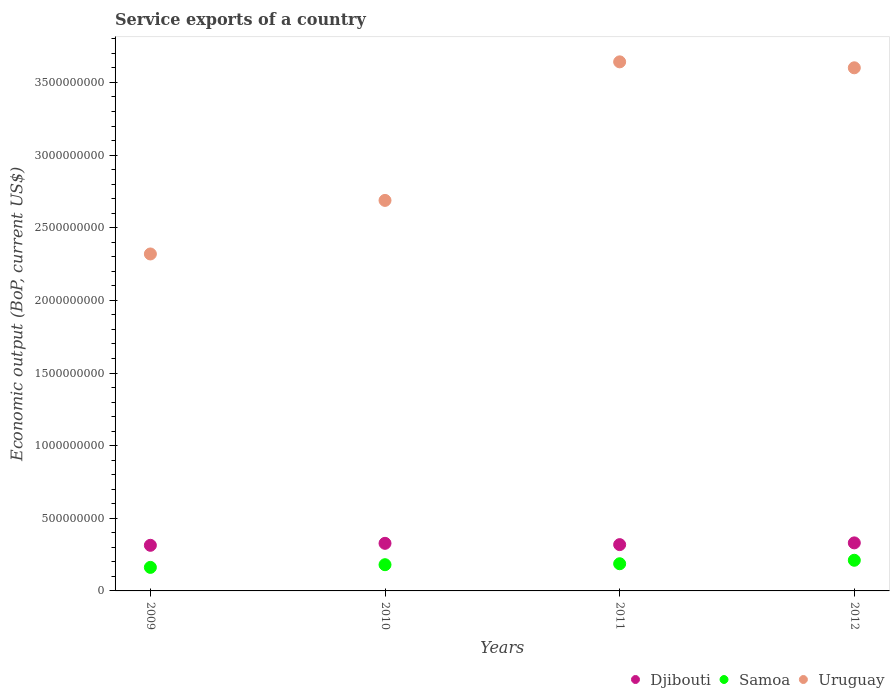How many different coloured dotlines are there?
Provide a succinct answer. 3. Is the number of dotlines equal to the number of legend labels?
Keep it short and to the point. Yes. What is the service exports in Djibouti in 2012?
Provide a short and direct response. 3.31e+08. Across all years, what is the maximum service exports in Uruguay?
Your response must be concise. 3.64e+09. Across all years, what is the minimum service exports in Samoa?
Give a very brief answer. 1.62e+08. In which year was the service exports in Samoa maximum?
Offer a very short reply. 2012. What is the total service exports in Samoa in the graph?
Your response must be concise. 7.41e+08. What is the difference between the service exports in Uruguay in 2009 and that in 2012?
Make the answer very short. -1.28e+09. What is the difference between the service exports in Uruguay in 2009 and the service exports in Djibouti in 2010?
Your answer should be very brief. 1.99e+09. What is the average service exports in Uruguay per year?
Your response must be concise. 3.06e+09. In the year 2009, what is the difference between the service exports in Samoa and service exports in Uruguay?
Give a very brief answer. -2.16e+09. What is the ratio of the service exports in Samoa in 2009 to that in 2011?
Offer a terse response. 0.87. What is the difference between the highest and the second highest service exports in Djibouti?
Provide a succinct answer. 3.07e+06. What is the difference between the highest and the lowest service exports in Djibouti?
Ensure brevity in your answer.  1.67e+07. Is the sum of the service exports in Djibouti in 2011 and 2012 greater than the maximum service exports in Samoa across all years?
Offer a very short reply. Yes. Is it the case that in every year, the sum of the service exports in Djibouti and service exports in Samoa  is greater than the service exports in Uruguay?
Make the answer very short. No. Is the service exports in Uruguay strictly less than the service exports in Samoa over the years?
Offer a very short reply. No. How many years are there in the graph?
Make the answer very short. 4. Are the values on the major ticks of Y-axis written in scientific E-notation?
Your response must be concise. No. Does the graph contain grids?
Provide a short and direct response. No. What is the title of the graph?
Offer a very short reply. Service exports of a country. What is the label or title of the X-axis?
Ensure brevity in your answer.  Years. What is the label or title of the Y-axis?
Ensure brevity in your answer.  Economic output (BoP, current US$). What is the Economic output (BoP, current US$) of Djibouti in 2009?
Keep it short and to the point. 3.14e+08. What is the Economic output (BoP, current US$) of Samoa in 2009?
Make the answer very short. 1.62e+08. What is the Economic output (BoP, current US$) of Uruguay in 2009?
Give a very brief answer. 2.32e+09. What is the Economic output (BoP, current US$) in Djibouti in 2010?
Your response must be concise. 3.28e+08. What is the Economic output (BoP, current US$) in Samoa in 2010?
Your answer should be very brief. 1.80e+08. What is the Economic output (BoP, current US$) in Uruguay in 2010?
Your response must be concise. 2.69e+09. What is the Economic output (BoP, current US$) in Djibouti in 2011?
Your response must be concise. 3.19e+08. What is the Economic output (BoP, current US$) in Samoa in 2011?
Give a very brief answer. 1.87e+08. What is the Economic output (BoP, current US$) in Uruguay in 2011?
Make the answer very short. 3.64e+09. What is the Economic output (BoP, current US$) of Djibouti in 2012?
Your response must be concise. 3.31e+08. What is the Economic output (BoP, current US$) in Samoa in 2012?
Your response must be concise. 2.11e+08. What is the Economic output (BoP, current US$) of Uruguay in 2012?
Your answer should be very brief. 3.60e+09. Across all years, what is the maximum Economic output (BoP, current US$) of Djibouti?
Provide a succinct answer. 3.31e+08. Across all years, what is the maximum Economic output (BoP, current US$) in Samoa?
Your answer should be compact. 2.11e+08. Across all years, what is the maximum Economic output (BoP, current US$) of Uruguay?
Offer a very short reply. 3.64e+09. Across all years, what is the minimum Economic output (BoP, current US$) of Djibouti?
Your answer should be compact. 3.14e+08. Across all years, what is the minimum Economic output (BoP, current US$) in Samoa?
Offer a terse response. 1.62e+08. Across all years, what is the minimum Economic output (BoP, current US$) of Uruguay?
Offer a terse response. 2.32e+09. What is the total Economic output (BoP, current US$) in Djibouti in the graph?
Provide a succinct answer. 1.29e+09. What is the total Economic output (BoP, current US$) of Samoa in the graph?
Keep it short and to the point. 7.41e+08. What is the total Economic output (BoP, current US$) in Uruguay in the graph?
Offer a very short reply. 1.23e+1. What is the difference between the Economic output (BoP, current US$) of Djibouti in 2009 and that in 2010?
Your response must be concise. -1.36e+07. What is the difference between the Economic output (BoP, current US$) in Samoa in 2009 and that in 2010?
Give a very brief answer. -1.84e+07. What is the difference between the Economic output (BoP, current US$) in Uruguay in 2009 and that in 2010?
Make the answer very short. -3.69e+08. What is the difference between the Economic output (BoP, current US$) of Djibouti in 2009 and that in 2011?
Keep it short and to the point. -4.65e+06. What is the difference between the Economic output (BoP, current US$) of Samoa in 2009 and that in 2011?
Give a very brief answer. -2.50e+07. What is the difference between the Economic output (BoP, current US$) in Uruguay in 2009 and that in 2011?
Give a very brief answer. -1.32e+09. What is the difference between the Economic output (BoP, current US$) in Djibouti in 2009 and that in 2012?
Your answer should be compact. -1.67e+07. What is the difference between the Economic output (BoP, current US$) in Samoa in 2009 and that in 2012?
Your answer should be very brief. -4.90e+07. What is the difference between the Economic output (BoP, current US$) of Uruguay in 2009 and that in 2012?
Give a very brief answer. -1.28e+09. What is the difference between the Economic output (BoP, current US$) in Djibouti in 2010 and that in 2011?
Ensure brevity in your answer.  8.94e+06. What is the difference between the Economic output (BoP, current US$) in Samoa in 2010 and that in 2011?
Your response must be concise. -6.60e+06. What is the difference between the Economic output (BoP, current US$) in Uruguay in 2010 and that in 2011?
Keep it short and to the point. -9.54e+08. What is the difference between the Economic output (BoP, current US$) of Djibouti in 2010 and that in 2012?
Provide a succinct answer. -3.07e+06. What is the difference between the Economic output (BoP, current US$) of Samoa in 2010 and that in 2012?
Offer a very short reply. -3.06e+07. What is the difference between the Economic output (BoP, current US$) of Uruguay in 2010 and that in 2012?
Your answer should be very brief. -9.13e+08. What is the difference between the Economic output (BoP, current US$) in Djibouti in 2011 and that in 2012?
Your response must be concise. -1.20e+07. What is the difference between the Economic output (BoP, current US$) in Samoa in 2011 and that in 2012?
Provide a succinct answer. -2.40e+07. What is the difference between the Economic output (BoP, current US$) in Uruguay in 2011 and that in 2012?
Your response must be concise. 4.10e+07. What is the difference between the Economic output (BoP, current US$) of Djibouti in 2009 and the Economic output (BoP, current US$) of Samoa in 2010?
Your response must be concise. 1.34e+08. What is the difference between the Economic output (BoP, current US$) in Djibouti in 2009 and the Economic output (BoP, current US$) in Uruguay in 2010?
Ensure brevity in your answer.  -2.37e+09. What is the difference between the Economic output (BoP, current US$) in Samoa in 2009 and the Economic output (BoP, current US$) in Uruguay in 2010?
Ensure brevity in your answer.  -2.53e+09. What is the difference between the Economic output (BoP, current US$) of Djibouti in 2009 and the Economic output (BoP, current US$) of Samoa in 2011?
Offer a very short reply. 1.27e+08. What is the difference between the Economic output (BoP, current US$) in Djibouti in 2009 and the Economic output (BoP, current US$) in Uruguay in 2011?
Keep it short and to the point. -3.33e+09. What is the difference between the Economic output (BoP, current US$) in Samoa in 2009 and the Economic output (BoP, current US$) in Uruguay in 2011?
Give a very brief answer. -3.48e+09. What is the difference between the Economic output (BoP, current US$) in Djibouti in 2009 and the Economic output (BoP, current US$) in Samoa in 2012?
Your answer should be very brief. 1.03e+08. What is the difference between the Economic output (BoP, current US$) of Djibouti in 2009 and the Economic output (BoP, current US$) of Uruguay in 2012?
Provide a short and direct response. -3.29e+09. What is the difference between the Economic output (BoP, current US$) in Samoa in 2009 and the Economic output (BoP, current US$) in Uruguay in 2012?
Your answer should be very brief. -3.44e+09. What is the difference between the Economic output (BoP, current US$) in Djibouti in 2010 and the Economic output (BoP, current US$) in Samoa in 2011?
Your response must be concise. 1.41e+08. What is the difference between the Economic output (BoP, current US$) of Djibouti in 2010 and the Economic output (BoP, current US$) of Uruguay in 2011?
Offer a very short reply. -3.31e+09. What is the difference between the Economic output (BoP, current US$) in Samoa in 2010 and the Economic output (BoP, current US$) in Uruguay in 2011?
Offer a very short reply. -3.46e+09. What is the difference between the Economic output (BoP, current US$) of Djibouti in 2010 and the Economic output (BoP, current US$) of Samoa in 2012?
Give a very brief answer. 1.17e+08. What is the difference between the Economic output (BoP, current US$) of Djibouti in 2010 and the Economic output (BoP, current US$) of Uruguay in 2012?
Your answer should be compact. -3.27e+09. What is the difference between the Economic output (BoP, current US$) of Samoa in 2010 and the Economic output (BoP, current US$) of Uruguay in 2012?
Ensure brevity in your answer.  -3.42e+09. What is the difference between the Economic output (BoP, current US$) of Djibouti in 2011 and the Economic output (BoP, current US$) of Samoa in 2012?
Provide a short and direct response. 1.08e+08. What is the difference between the Economic output (BoP, current US$) in Djibouti in 2011 and the Economic output (BoP, current US$) in Uruguay in 2012?
Offer a terse response. -3.28e+09. What is the difference between the Economic output (BoP, current US$) of Samoa in 2011 and the Economic output (BoP, current US$) of Uruguay in 2012?
Give a very brief answer. -3.41e+09. What is the average Economic output (BoP, current US$) of Djibouti per year?
Offer a terse response. 3.23e+08. What is the average Economic output (BoP, current US$) in Samoa per year?
Offer a terse response. 1.85e+08. What is the average Economic output (BoP, current US$) in Uruguay per year?
Provide a succinct answer. 3.06e+09. In the year 2009, what is the difference between the Economic output (BoP, current US$) of Djibouti and Economic output (BoP, current US$) of Samoa?
Your response must be concise. 1.52e+08. In the year 2009, what is the difference between the Economic output (BoP, current US$) in Djibouti and Economic output (BoP, current US$) in Uruguay?
Your answer should be compact. -2.01e+09. In the year 2009, what is the difference between the Economic output (BoP, current US$) of Samoa and Economic output (BoP, current US$) of Uruguay?
Your answer should be very brief. -2.16e+09. In the year 2010, what is the difference between the Economic output (BoP, current US$) of Djibouti and Economic output (BoP, current US$) of Samoa?
Provide a succinct answer. 1.47e+08. In the year 2010, what is the difference between the Economic output (BoP, current US$) of Djibouti and Economic output (BoP, current US$) of Uruguay?
Offer a terse response. -2.36e+09. In the year 2010, what is the difference between the Economic output (BoP, current US$) of Samoa and Economic output (BoP, current US$) of Uruguay?
Give a very brief answer. -2.51e+09. In the year 2011, what is the difference between the Economic output (BoP, current US$) in Djibouti and Economic output (BoP, current US$) in Samoa?
Offer a terse response. 1.32e+08. In the year 2011, what is the difference between the Economic output (BoP, current US$) of Djibouti and Economic output (BoP, current US$) of Uruguay?
Provide a succinct answer. -3.32e+09. In the year 2011, what is the difference between the Economic output (BoP, current US$) of Samoa and Economic output (BoP, current US$) of Uruguay?
Provide a succinct answer. -3.45e+09. In the year 2012, what is the difference between the Economic output (BoP, current US$) in Djibouti and Economic output (BoP, current US$) in Samoa?
Offer a terse response. 1.20e+08. In the year 2012, what is the difference between the Economic output (BoP, current US$) in Djibouti and Economic output (BoP, current US$) in Uruguay?
Provide a succinct answer. -3.27e+09. In the year 2012, what is the difference between the Economic output (BoP, current US$) of Samoa and Economic output (BoP, current US$) of Uruguay?
Your answer should be compact. -3.39e+09. What is the ratio of the Economic output (BoP, current US$) in Djibouti in 2009 to that in 2010?
Your answer should be very brief. 0.96. What is the ratio of the Economic output (BoP, current US$) of Samoa in 2009 to that in 2010?
Give a very brief answer. 0.9. What is the ratio of the Economic output (BoP, current US$) in Uruguay in 2009 to that in 2010?
Your response must be concise. 0.86. What is the ratio of the Economic output (BoP, current US$) of Djibouti in 2009 to that in 2011?
Your answer should be compact. 0.99. What is the ratio of the Economic output (BoP, current US$) of Samoa in 2009 to that in 2011?
Make the answer very short. 0.87. What is the ratio of the Economic output (BoP, current US$) in Uruguay in 2009 to that in 2011?
Your answer should be compact. 0.64. What is the ratio of the Economic output (BoP, current US$) in Djibouti in 2009 to that in 2012?
Ensure brevity in your answer.  0.95. What is the ratio of the Economic output (BoP, current US$) in Samoa in 2009 to that in 2012?
Your response must be concise. 0.77. What is the ratio of the Economic output (BoP, current US$) of Uruguay in 2009 to that in 2012?
Offer a very short reply. 0.64. What is the ratio of the Economic output (BoP, current US$) of Djibouti in 2010 to that in 2011?
Give a very brief answer. 1.03. What is the ratio of the Economic output (BoP, current US$) of Samoa in 2010 to that in 2011?
Your response must be concise. 0.96. What is the ratio of the Economic output (BoP, current US$) of Uruguay in 2010 to that in 2011?
Ensure brevity in your answer.  0.74. What is the ratio of the Economic output (BoP, current US$) of Djibouti in 2010 to that in 2012?
Keep it short and to the point. 0.99. What is the ratio of the Economic output (BoP, current US$) in Samoa in 2010 to that in 2012?
Make the answer very short. 0.86. What is the ratio of the Economic output (BoP, current US$) of Uruguay in 2010 to that in 2012?
Offer a terse response. 0.75. What is the ratio of the Economic output (BoP, current US$) of Djibouti in 2011 to that in 2012?
Provide a short and direct response. 0.96. What is the ratio of the Economic output (BoP, current US$) of Samoa in 2011 to that in 2012?
Your response must be concise. 0.89. What is the ratio of the Economic output (BoP, current US$) of Uruguay in 2011 to that in 2012?
Your response must be concise. 1.01. What is the difference between the highest and the second highest Economic output (BoP, current US$) of Djibouti?
Your answer should be compact. 3.07e+06. What is the difference between the highest and the second highest Economic output (BoP, current US$) of Samoa?
Give a very brief answer. 2.40e+07. What is the difference between the highest and the second highest Economic output (BoP, current US$) of Uruguay?
Provide a short and direct response. 4.10e+07. What is the difference between the highest and the lowest Economic output (BoP, current US$) of Djibouti?
Give a very brief answer. 1.67e+07. What is the difference between the highest and the lowest Economic output (BoP, current US$) in Samoa?
Ensure brevity in your answer.  4.90e+07. What is the difference between the highest and the lowest Economic output (BoP, current US$) of Uruguay?
Your answer should be very brief. 1.32e+09. 